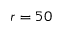<formula> <loc_0><loc_0><loc_500><loc_500>r = 5 0</formula> 